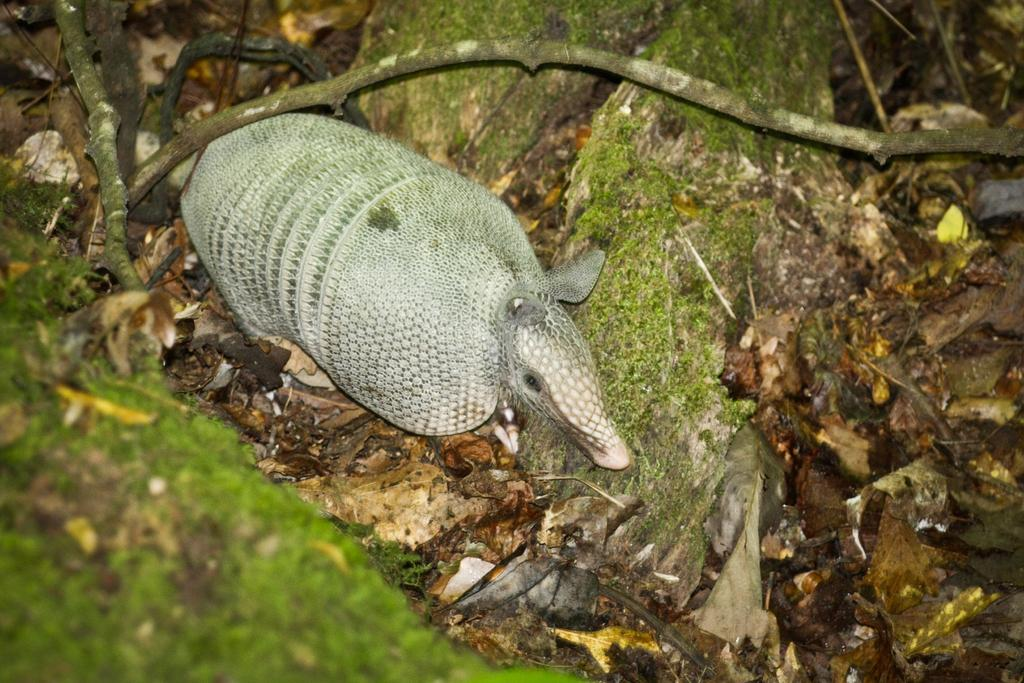What is the main subject of the image? There is an animal on a stone in the image. What can be seen at the bottom of the image? Dry leaves and barks are visible at the bottom of the image. What type of throne is the animal sitting on in the image? There is no throne present in the image; the animal is sitting on a stone. 